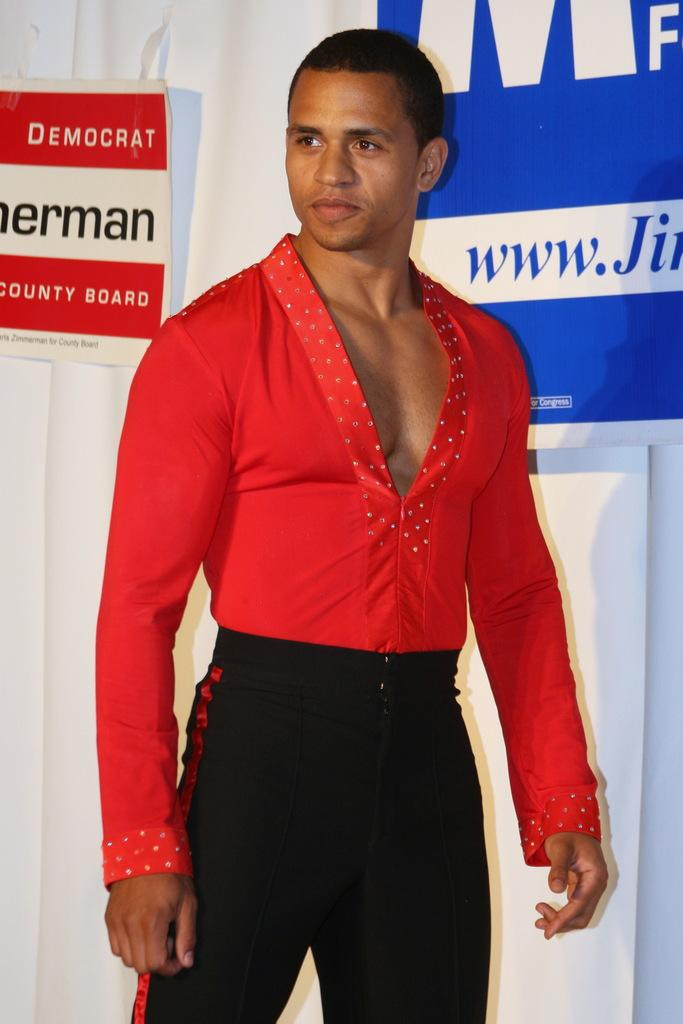What is the main subject of the image? There is a man standing in the image. Where is the man positioned in the image? The man is standing on the floor. What can be seen in the background of the image? There are advertisements in the background of the image. How are the advertisements displayed in the image? The advertisements are attached to a curtain. What type of collar is the man wearing in the image? There is no collar visible in the image, as the man is not wearing any clothing or accessories that would have a collar. 